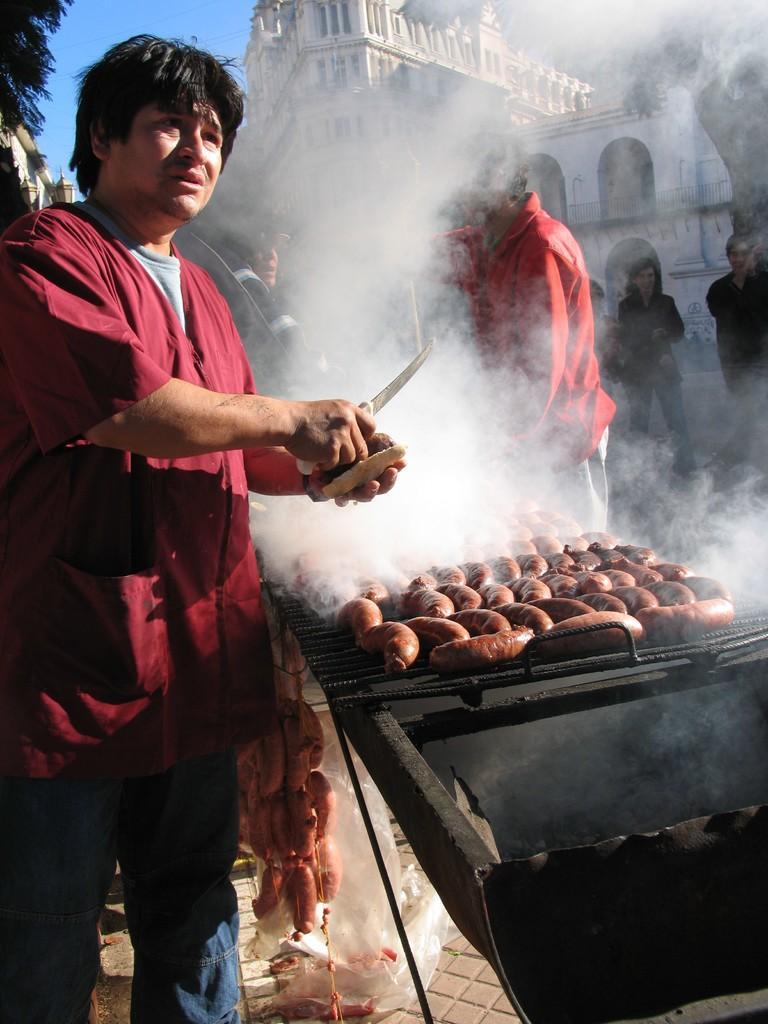Describe this image in one or two sentences. This picture describes about group of people, on the left side of the image we can see a man, he is holding a knife and a sausage, in front of him we can see food on the barbecue, in the background we can find few buildings and trees. 